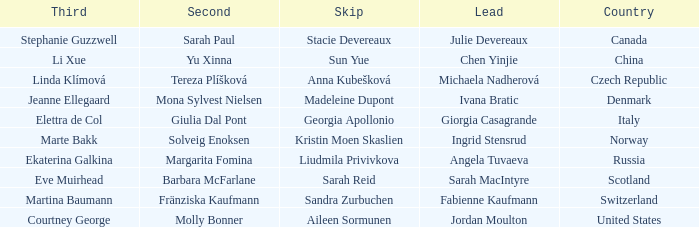Parse the table in full. {'header': ['Third', 'Second', 'Skip', 'Lead', 'Country'], 'rows': [['Stephanie Guzzwell', 'Sarah Paul', 'Stacie Devereaux', 'Julie Devereaux', 'Canada'], ['Li Xue', 'Yu Xinna', 'Sun Yue', 'Chen Yinjie', 'China'], ['Linda Klímová', 'Tereza Plíšková', 'Anna Kubešková', 'Michaela Nadherová', 'Czech Republic'], ['Jeanne Ellegaard', 'Mona Sylvest Nielsen', 'Madeleine Dupont', 'Ivana Bratic', 'Denmark'], ['Elettra de Col', 'Giulia Dal Pont', 'Georgia Apollonio', 'Giorgia Casagrande', 'Italy'], ['Marte Bakk', 'Solveig Enoksen', 'Kristin Moen Skaslien', 'Ingrid Stensrud', 'Norway'], ['Ekaterina Galkina', 'Margarita Fomina', 'Liudmila Privivkova', 'Angela Tuvaeva', 'Russia'], ['Eve Muirhead', 'Barbara McFarlane', 'Sarah Reid', 'Sarah MacIntyre', 'Scotland'], ['Martina Baumann', 'Fränziska Kaufmann', 'Sandra Zurbuchen', 'Fabienne Kaufmann', 'Switzerland'], ['Courtney George', 'Molly Bonner', 'Aileen Sormunen', 'Jordan Moulton', 'United States']]} What skip has angela tuvaeva as the lead? Liudmila Privivkova. 